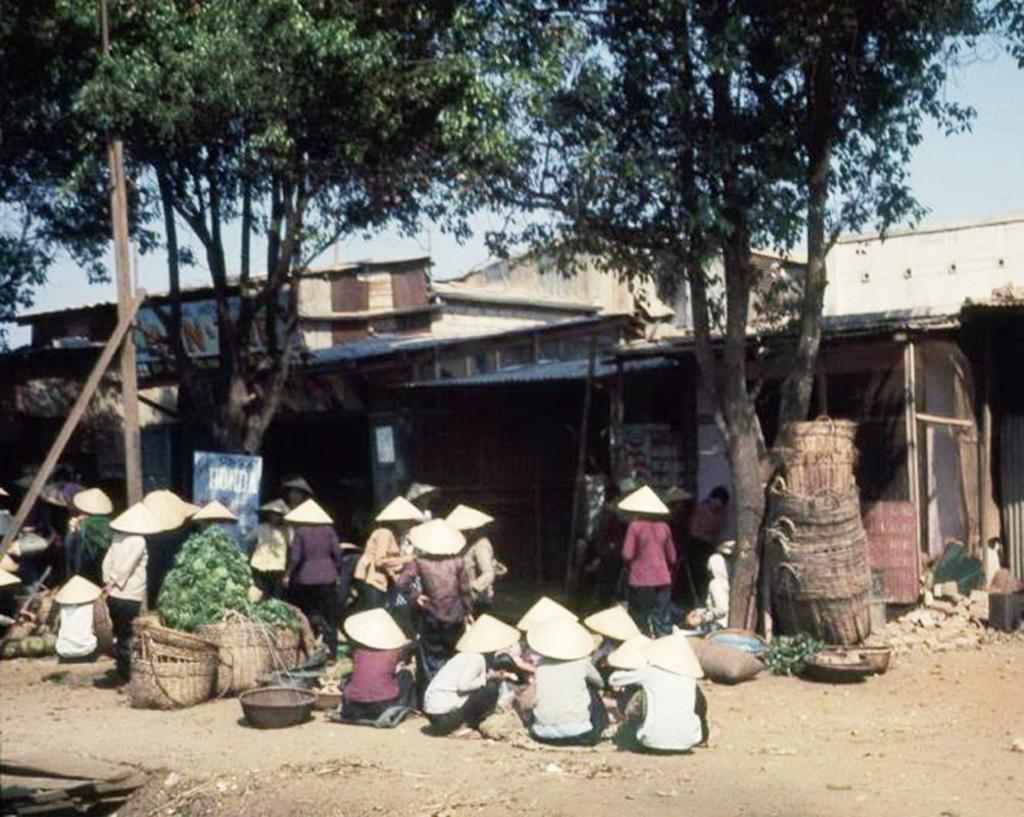Can you describe this image briefly? On the right side of the image we can see a tree, containers, building and some vegetables. At the bottom of the image we can see a ground, vegetables, containers, persons. On the left side of the image we can see a person's, pole, tree and building. In the background there is a sky. 